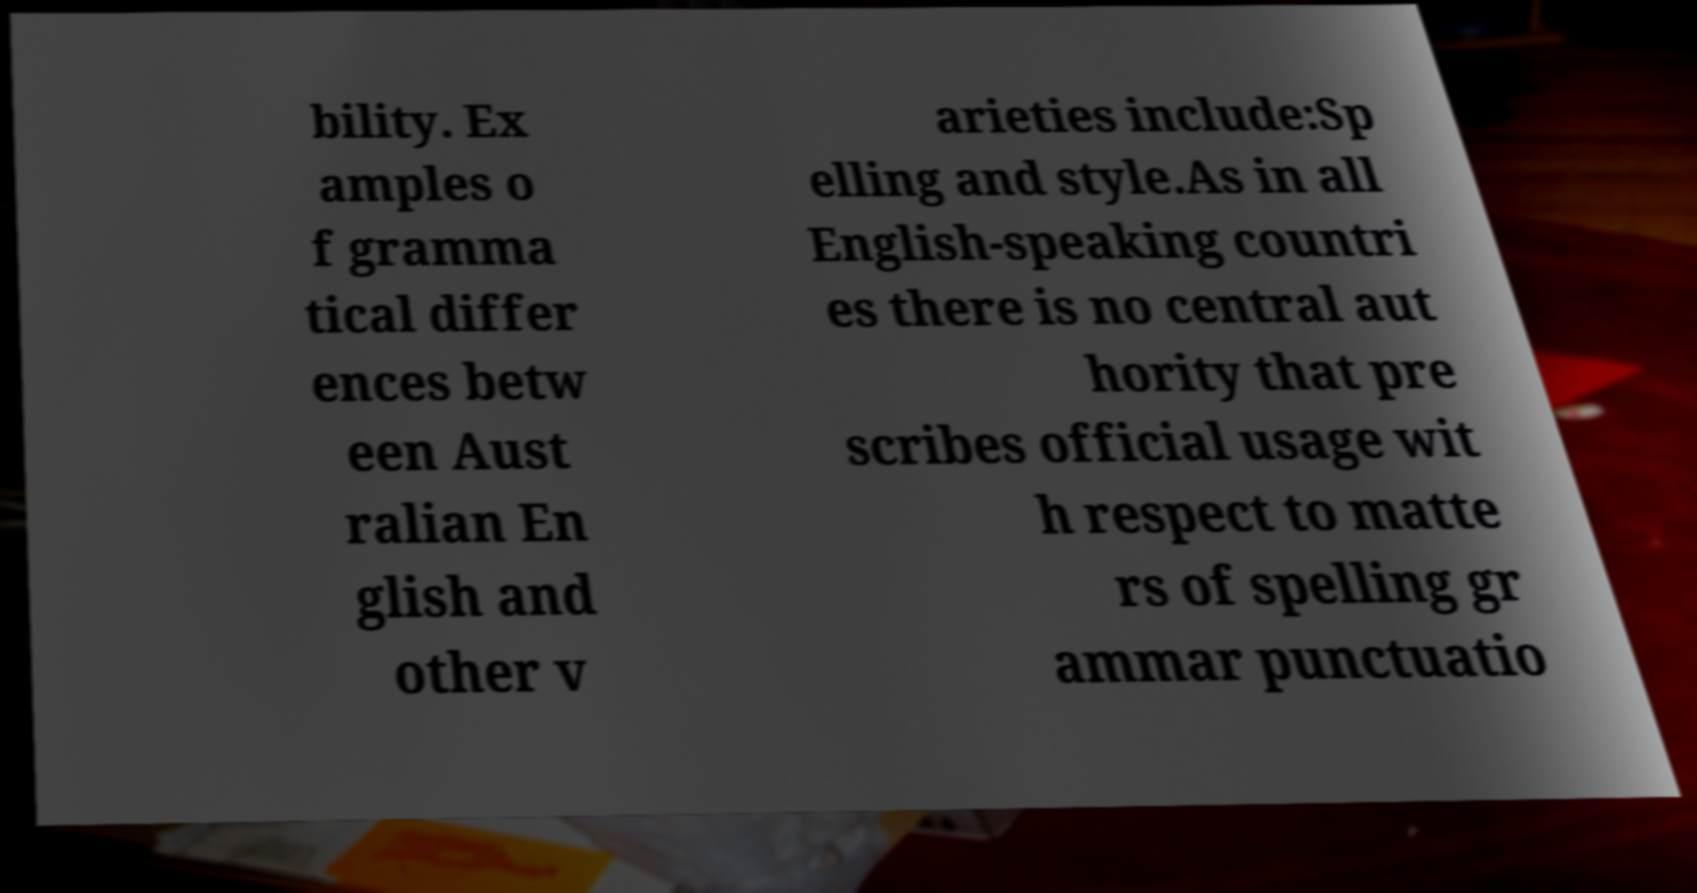For documentation purposes, I need the text within this image transcribed. Could you provide that? bility. Ex amples o f gramma tical differ ences betw een Aust ralian En glish and other v arieties include:Sp elling and style.As in all English-speaking countri es there is no central aut hority that pre scribes official usage wit h respect to matte rs of spelling gr ammar punctuatio 